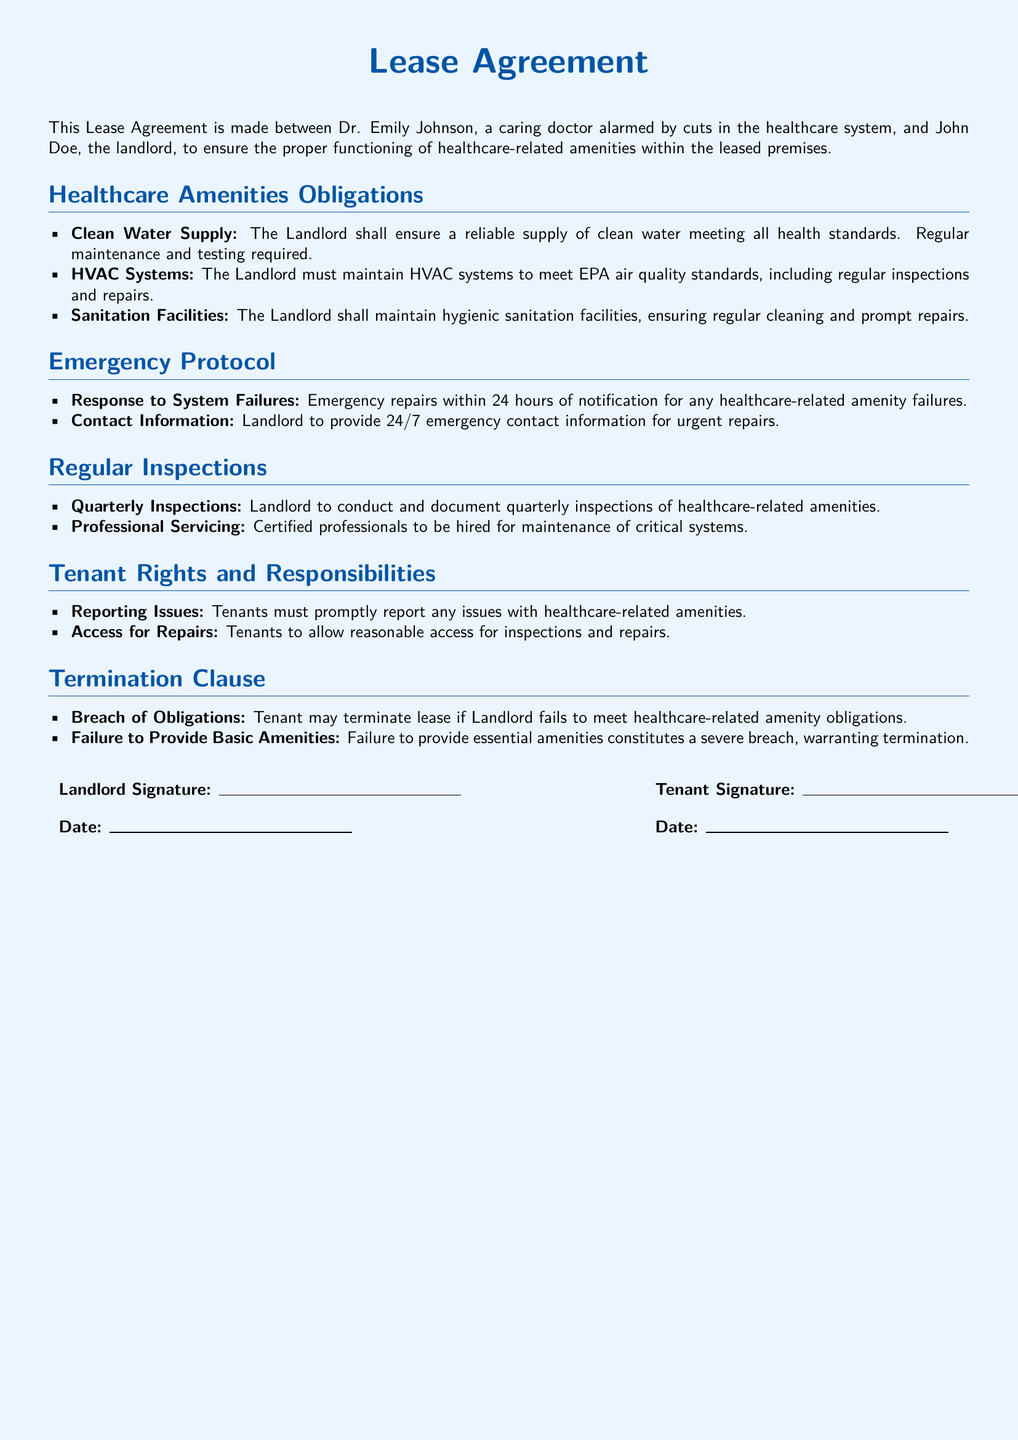What are the healthcare amenities obligations? The document lists the obligations of the landlord regarding healthcare amenities, which include clean water supply, HVAC systems, and sanitation facilities.
Answer: Clean water supply, HVAC systems, sanitation facilities What is the response time for emergency repairs? The document specifies that emergency repairs must be completed within 24 hours of notification for any healthcare-related amenity failures.
Answer: 24 hours Who is responsible for conducting regular inspections? The landlord is responsible for conducting and documenting quarterly inspections of healthcare-related amenities as stated in the document.
Answer: Landlord What happens if the landlord fails to provide basic amenities? The document states that failure to provide essential amenities constitutes a severe breach, allowing the tenant to terminate the lease.
Answer: Termination How often are the quarterly inspections to be conducted? The inspections are to be conducted quarterly, as mentioned in the document.
Answer: Quarterly What professional standard must HVAC systems meet? The document mentions that HVAC systems must meet EPA air quality standards.
Answer: EPA air quality standards What information must the landlord provide for emergencies? The landlord is required to provide 24/7 emergency contact information for urgent repairs.
Answer: 24/7 emergency contact information What actions must tenants take if issues arise? Tenants are required to promptly report any issues with healthcare-related amenities according to the document.
Answer: Promptly report What constitutes a breach of obligations? The document defines a breach of obligations as failure to meet healthcare-related amenity requirements or failure to provide essential amenities.
Answer: Failure to meet healthcare-related amenity obligations 